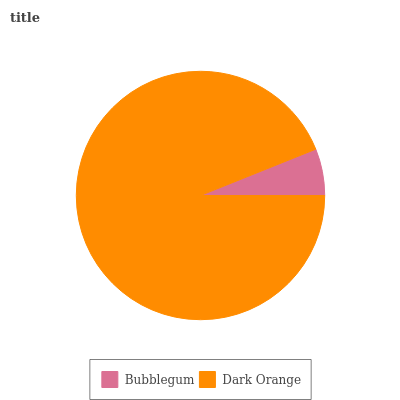Is Bubblegum the minimum?
Answer yes or no. Yes. Is Dark Orange the maximum?
Answer yes or no. Yes. Is Dark Orange the minimum?
Answer yes or no. No. Is Dark Orange greater than Bubblegum?
Answer yes or no. Yes. Is Bubblegum less than Dark Orange?
Answer yes or no. Yes. Is Bubblegum greater than Dark Orange?
Answer yes or no. No. Is Dark Orange less than Bubblegum?
Answer yes or no. No. Is Dark Orange the high median?
Answer yes or no. Yes. Is Bubblegum the low median?
Answer yes or no. Yes. Is Bubblegum the high median?
Answer yes or no. No. Is Dark Orange the low median?
Answer yes or no. No. 